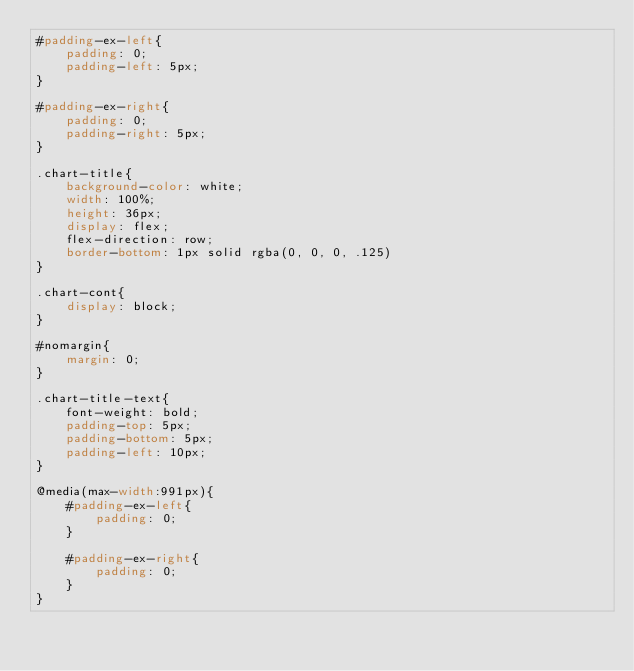<code> <loc_0><loc_0><loc_500><loc_500><_CSS_>#padding-ex-left{
    padding: 0;
    padding-left: 5px;
}

#padding-ex-right{
    padding: 0;
    padding-right: 5px;
}

.chart-title{
    background-color: white;
    width: 100%;
    height: 36px;
    display: flex;
    flex-direction: row;
    border-bottom: 1px solid rgba(0, 0, 0, .125)
}

.chart-cont{
    display: block;
}

#nomargin{
    margin: 0;
}

.chart-title-text{
    font-weight: bold;
    padding-top: 5px;
    padding-bottom: 5px;
    padding-left: 10px;
}

@media(max-width:991px){
    #padding-ex-left{
        padding: 0;
    }
    
    #padding-ex-right{
        padding: 0;
    }
}</code> 